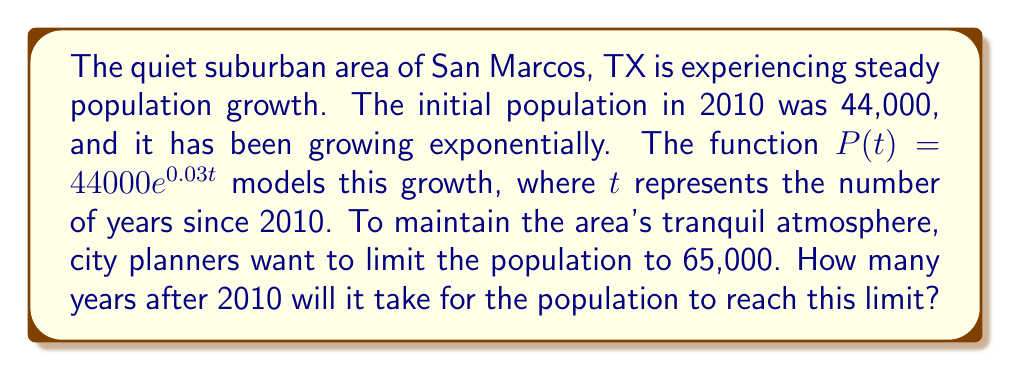Help me with this question. Let's approach this step-by-step:

1) We need to solve the equation:
   $65000 = 44000e^{0.03t}$

2) Divide both sides by 44000:
   $\frac{65000}{44000} = e^{0.03t}$

3) Take the natural logarithm of both sides:
   $\ln(\frac{65000}{44000}) = \ln(e^{0.03t})$

4) Simplify the right side using the property of logarithms:
   $\ln(\frac{65000}{44000}) = 0.03t$

5) Calculate the left side:
   $\ln(1.4772727...) = 0.03t$

6) Divide both sides by 0.03:
   $\frac{\ln(1.4772727...)}{0.03} = t$

7) Calculate the final result:
   $t \approx 13.0416$

8) Since we're dealing with years, we round up to the nearest whole year.
Answer: 14 years 